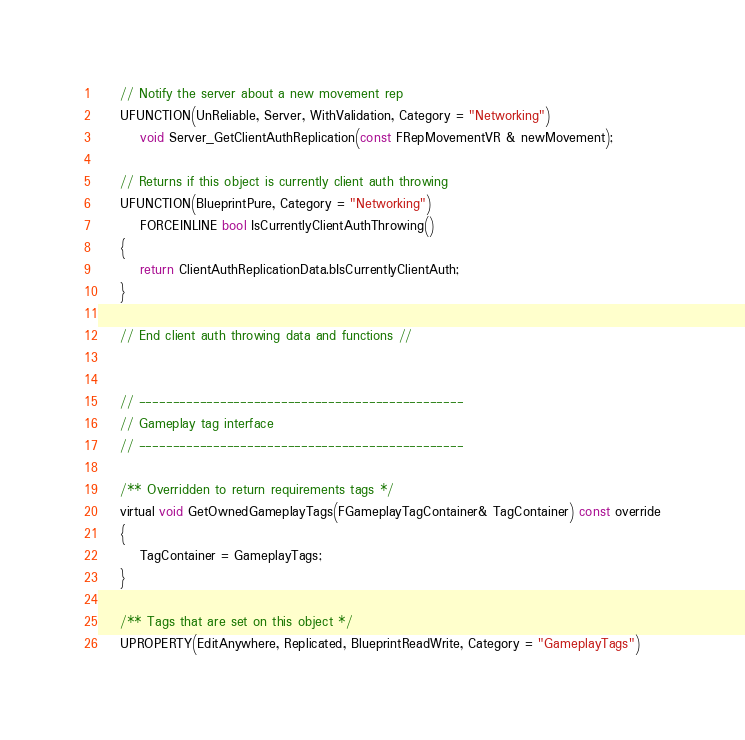Convert code to text. <code><loc_0><loc_0><loc_500><loc_500><_C_>
	// Notify the server about a new movement rep
	UFUNCTION(UnReliable, Server, WithValidation, Category = "Networking")
		void Server_GetClientAuthReplication(const FRepMovementVR & newMovement);

	// Returns if this object is currently client auth throwing
	UFUNCTION(BlueprintPure, Category = "Networking")
		FORCEINLINE bool IsCurrentlyClientAuthThrowing()
	{
		return ClientAuthReplicationData.bIsCurrentlyClientAuth;
	}

	// End client auth throwing data and functions //


	// ------------------------------------------------
	// Gameplay tag interface
	// ------------------------------------------------

	/** Overridden to return requirements tags */
	virtual void GetOwnedGameplayTags(FGameplayTagContainer& TagContainer) const override
	{
		TagContainer = GameplayTags;
	}

	/** Tags that are set on this object */
	UPROPERTY(EditAnywhere, Replicated, BlueprintReadWrite, Category = "GameplayTags")</code> 